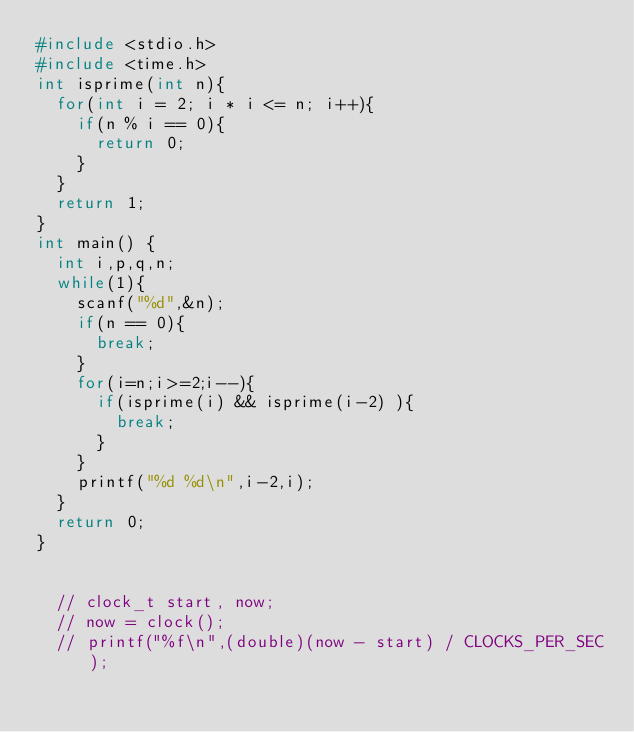<code> <loc_0><loc_0><loc_500><loc_500><_C++_>#include <stdio.h>
#include <time.h>
int isprime(int n){
	for(int i = 2; i * i <= n; i++){
		if(n % i == 0){
			return 0;
		}
	}
	return 1;
}
int main() {
	int i,p,q,n;
	while(1){
		scanf("%d",&n);
		if(n == 0){
			break;
		}
		for(i=n;i>=2;i--){
			if(isprime(i) && isprime(i-2) ){
				break;
			}
		}
		printf("%d %d\n",i-2,i);
	}
	return 0;
}


	// clock_t start, now;
	// now = clock();
	// printf("%f\n",(double)(now - start) / CLOCKS_PER_SEC);</code> 